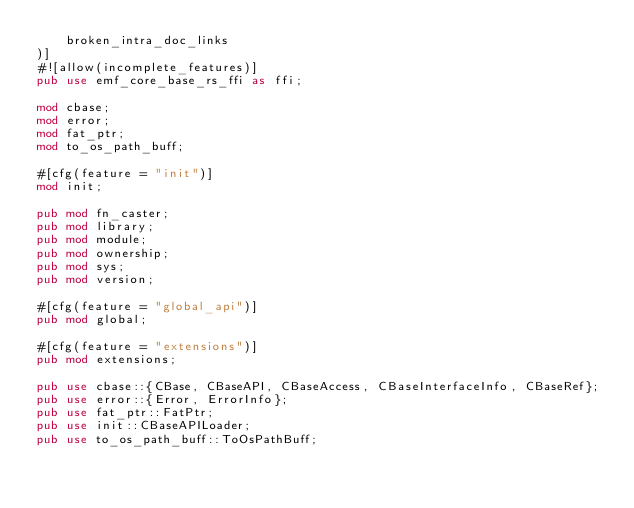Convert code to text. <code><loc_0><loc_0><loc_500><loc_500><_Rust_>    broken_intra_doc_links
)]
#![allow(incomplete_features)]
pub use emf_core_base_rs_ffi as ffi;

mod cbase;
mod error;
mod fat_ptr;
mod to_os_path_buff;

#[cfg(feature = "init")]
mod init;

pub mod fn_caster;
pub mod library;
pub mod module;
pub mod ownership;
pub mod sys;
pub mod version;

#[cfg(feature = "global_api")]
pub mod global;

#[cfg(feature = "extensions")]
pub mod extensions;

pub use cbase::{CBase, CBaseAPI, CBaseAccess, CBaseInterfaceInfo, CBaseRef};
pub use error::{Error, ErrorInfo};
pub use fat_ptr::FatPtr;
pub use init::CBaseAPILoader;
pub use to_os_path_buff::ToOsPathBuff;
</code> 